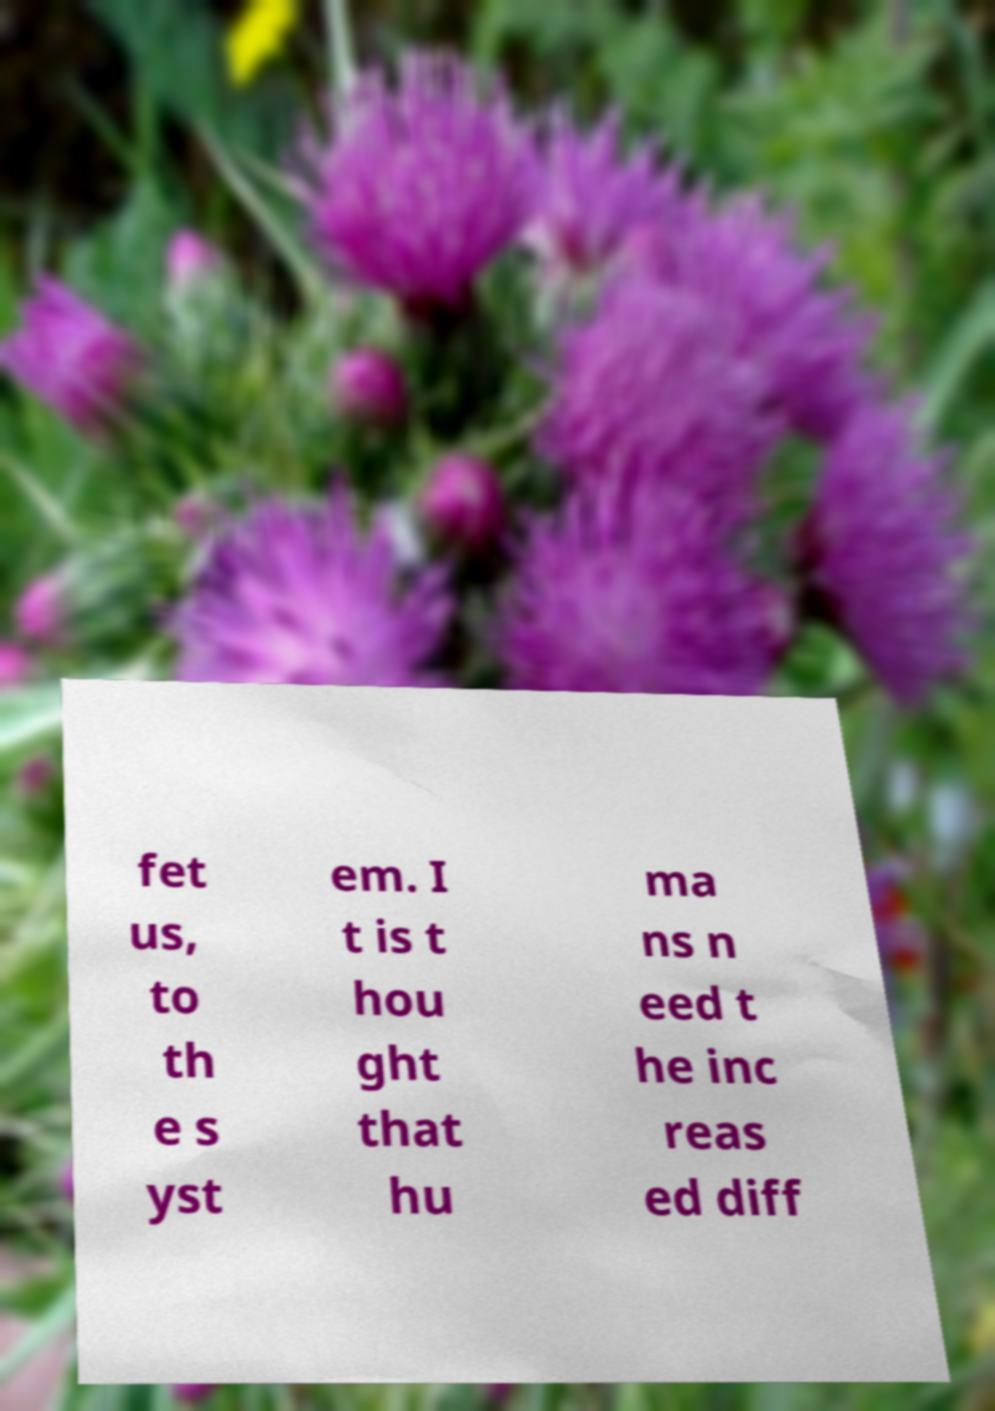Can you accurately transcribe the text from the provided image for me? fet us, to th e s yst em. I t is t hou ght that hu ma ns n eed t he inc reas ed diff 